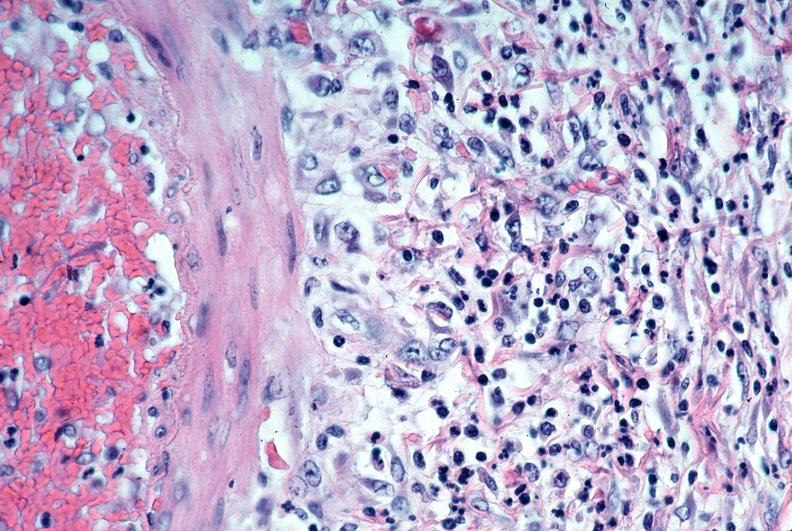what does this image show?
Answer the question using a single word or phrase. Vasculitis 